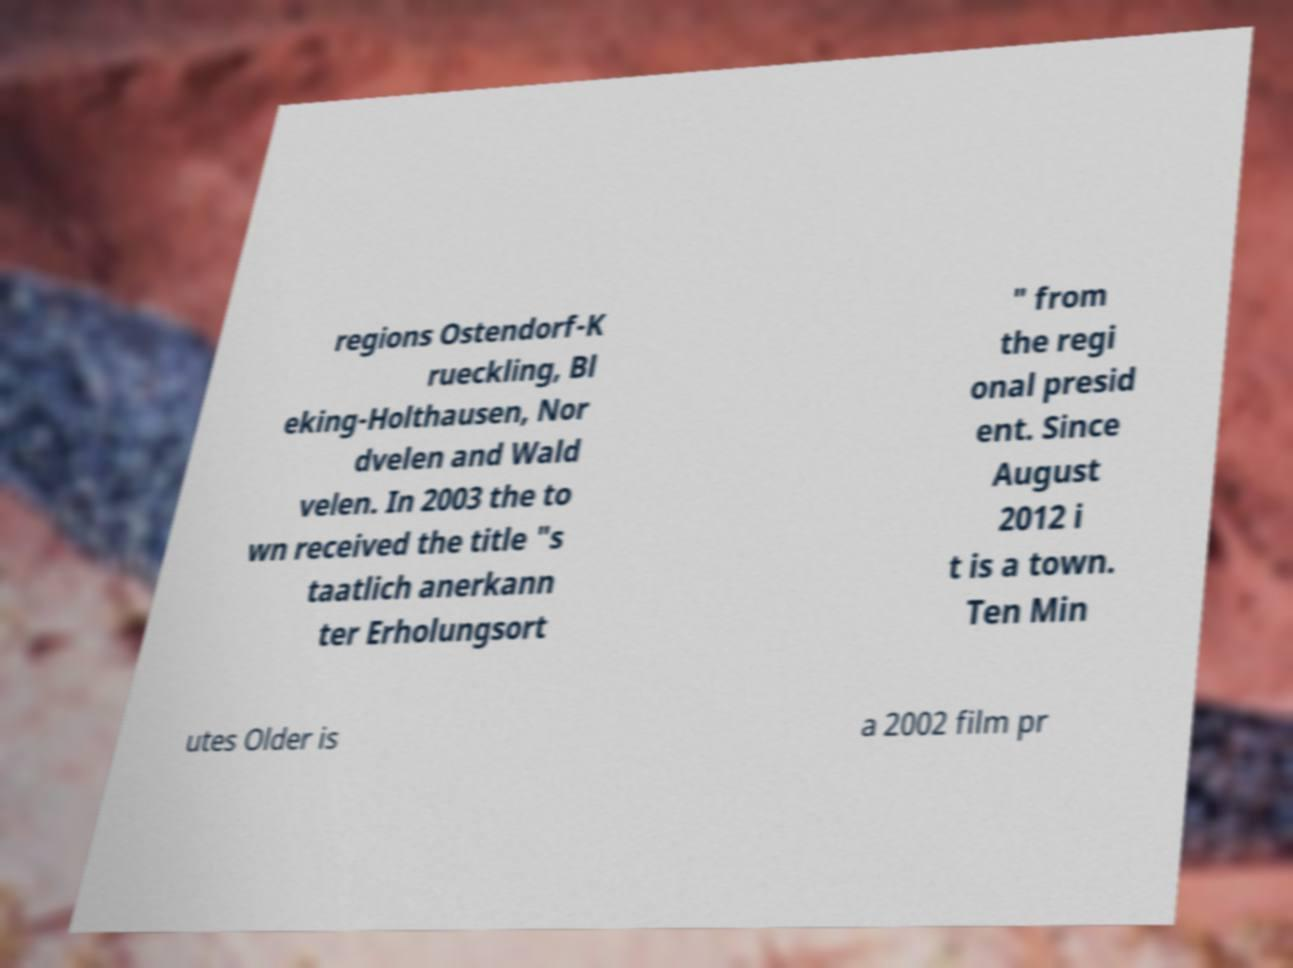Can you accurately transcribe the text from the provided image for me? regions Ostendorf-K rueckling, Bl eking-Holthausen, Nor dvelen and Wald velen. In 2003 the to wn received the title "s taatlich anerkann ter Erholungsort " from the regi onal presid ent. Since August 2012 i t is a town. Ten Min utes Older is a 2002 film pr 